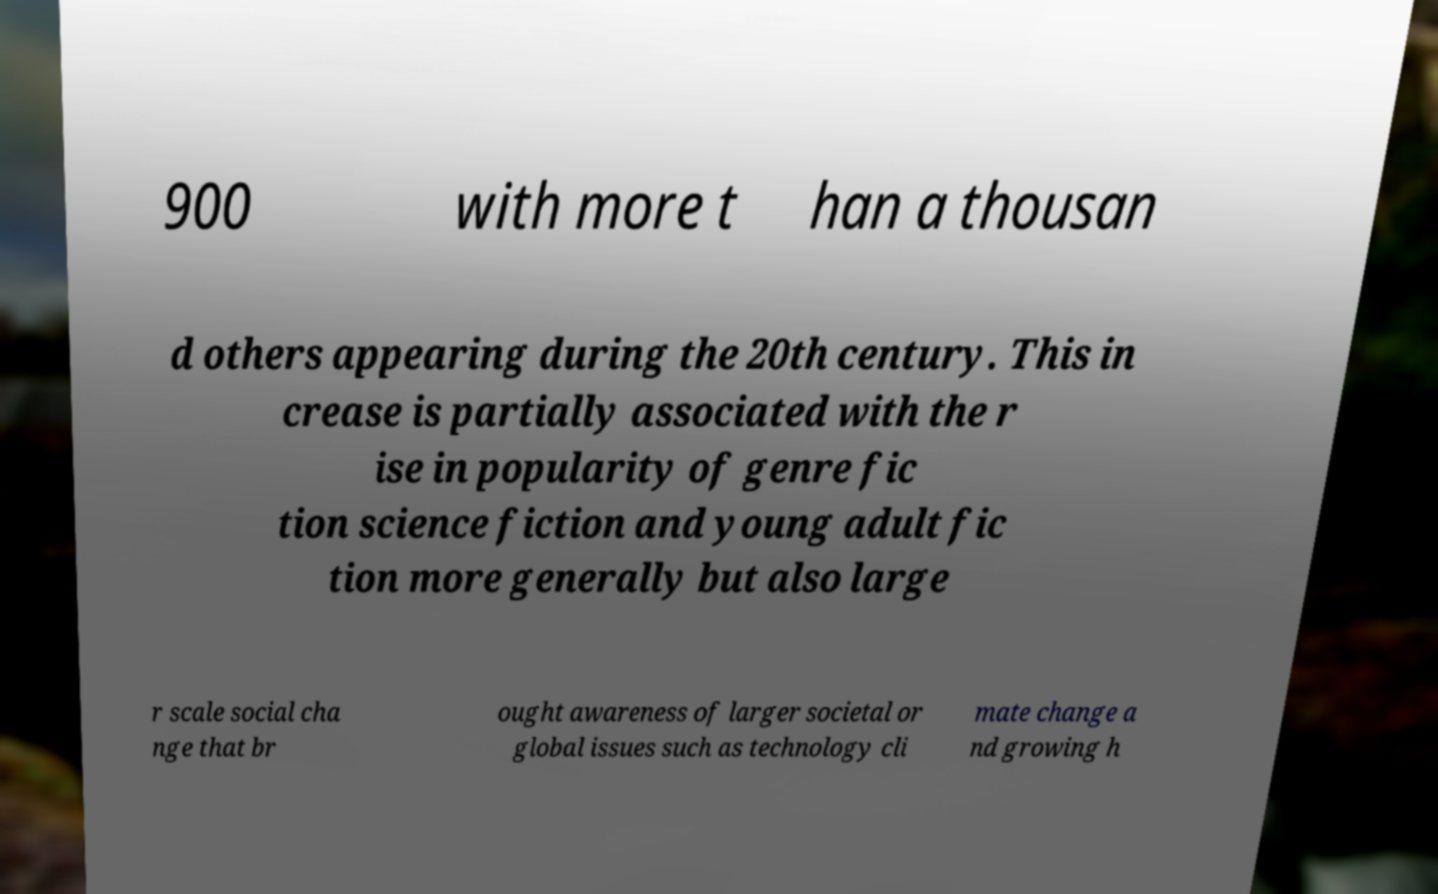I need the written content from this picture converted into text. Can you do that? 900 with more t han a thousan d others appearing during the 20th century. This in crease is partially associated with the r ise in popularity of genre fic tion science fiction and young adult fic tion more generally but also large r scale social cha nge that br ought awareness of larger societal or global issues such as technology cli mate change a nd growing h 